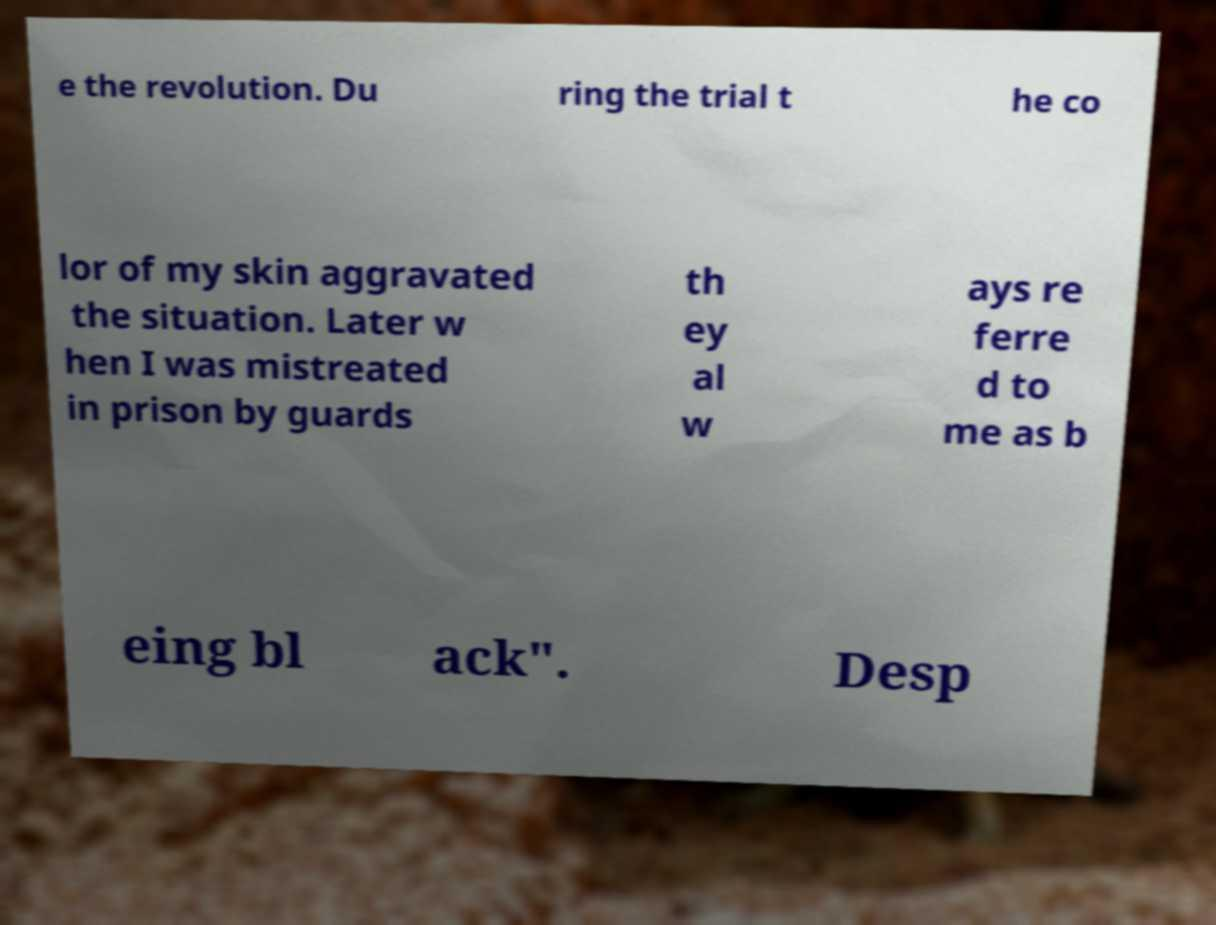Can you read and provide the text displayed in the image?This photo seems to have some interesting text. Can you extract and type it out for me? e the revolution. Du ring the trial t he co lor of my skin aggravated the situation. Later w hen I was mistreated in prison by guards th ey al w ays re ferre d to me as b eing bl ack". Desp 